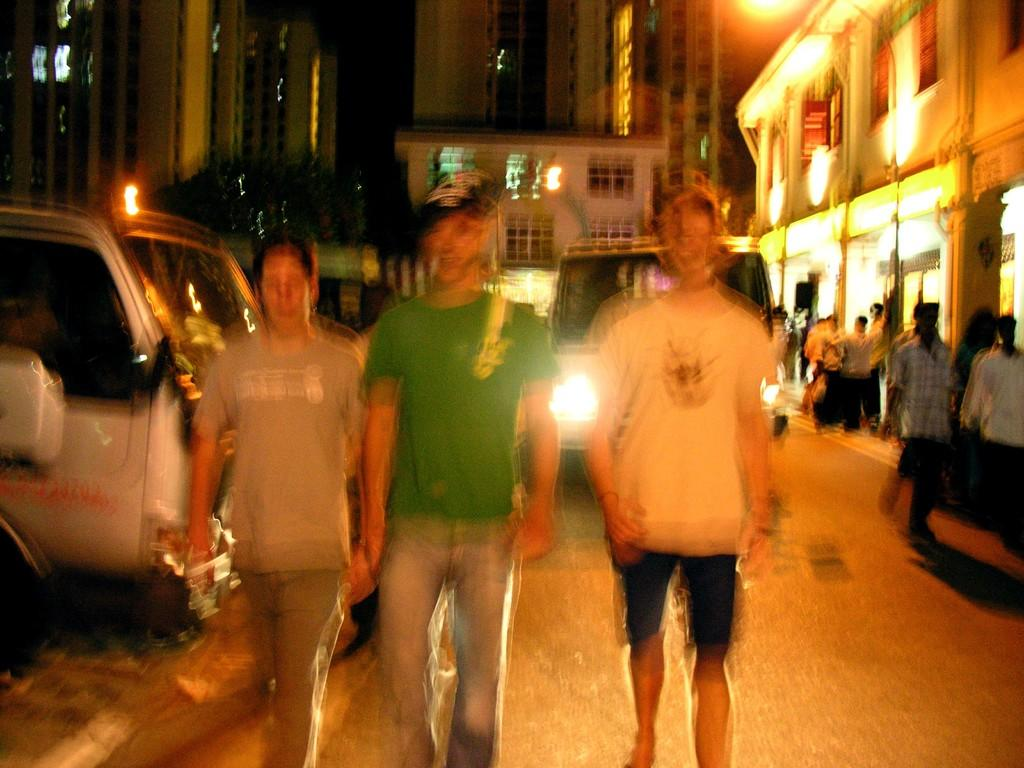How many people are in the group visible in the image? The number of people in the group cannot be determined from the provided facts. What type of vehicles can be seen on the road in the image? The specific type of vehicles cannot be determined from the provided facts. What can be seen in the background of the image? There are buildings with windows and a street light in the background of the image. What type of seat is visible in the image? There is no seat present in the image. What place is depicted in the image? The image does not depict a specific place; it shows a group of people, vehicles, buildings, and a street light. 